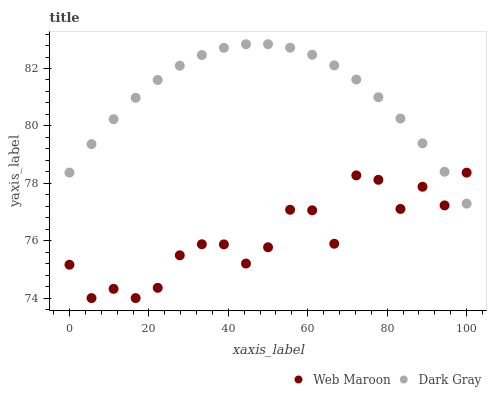Does Web Maroon have the minimum area under the curve?
Answer yes or no. Yes. Does Dark Gray have the maximum area under the curve?
Answer yes or no. Yes. Does Web Maroon have the maximum area under the curve?
Answer yes or no. No. Is Dark Gray the smoothest?
Answer yes or no. Yes. Is Web Maroon the roughest?
Answer yes or no. Yes. Is Web Maroon the smoothest?
Answer yes or no. No. Does Web Maroon have the lowest value?
Answer yes or no. Yes. Does Dark Gray have the highest value?
Answer yes or no. Yes. Does Web Maroon have the highest value?
Answer yes or no. No. Does Dark Gray intersect Web Maroon?
Answer yes or no. Yes. Is Dark Gray less than Web Maroon?
Answer yes or no. No. Is Dark Gray greater than Web Maroon?
Answer yes or no. No. 